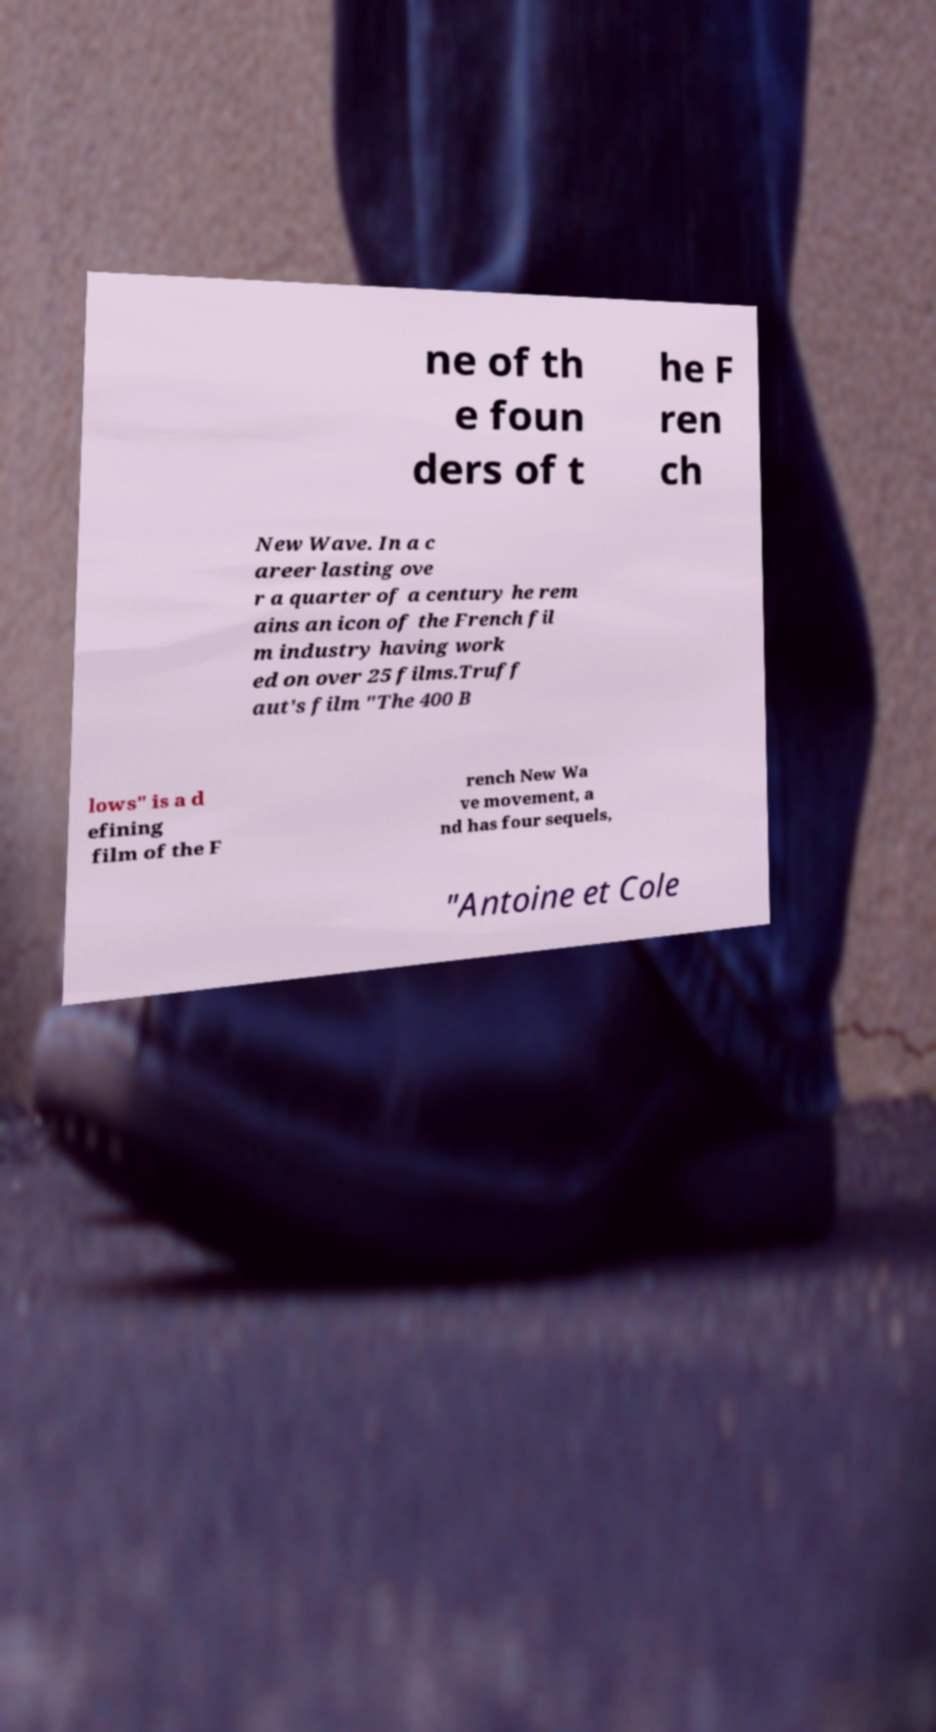For documentation purposes, I need the text within this image transcribed. Could you provide that? ne of th e foun ders of t he F ren ch New Wave. In a c areer lasting ove r a quarter of a century he rem ains an icon of the French fil m industry having work ed on over 25 films.Truff aut's film "The 400 B lows" is a d efining film of the F rench New Wa ve movement, a nd has four sequels, "Antoine et Cole 